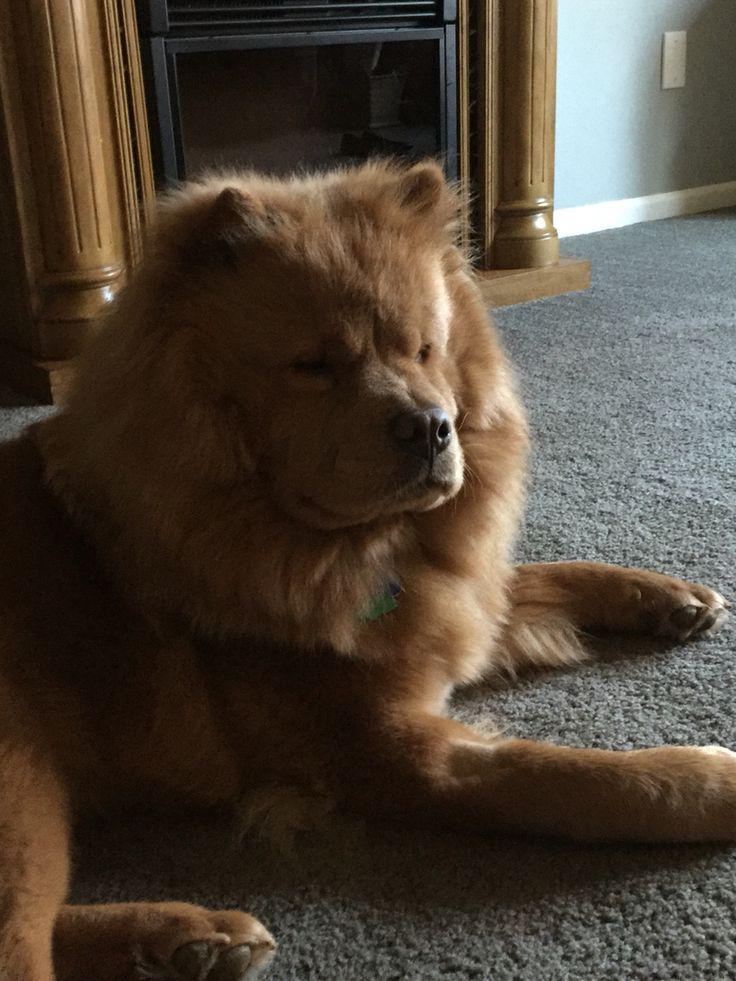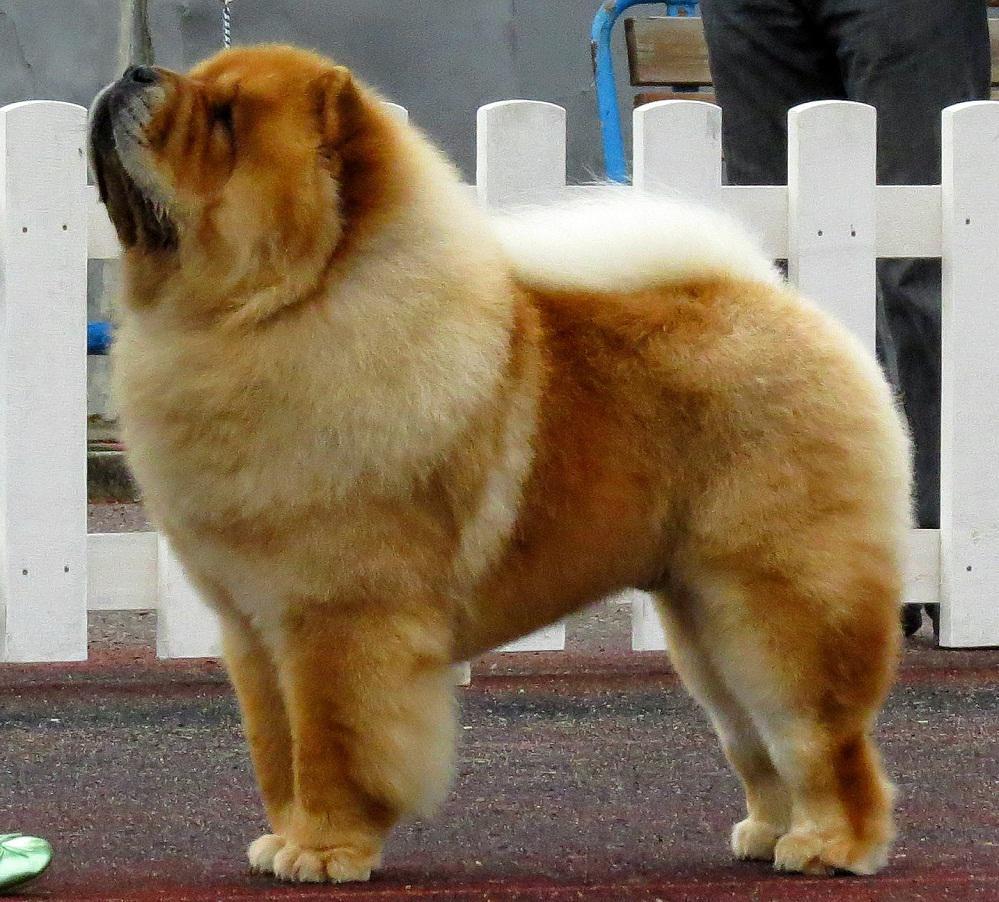The first image is the image on the left, the second image is the image on the right. Assess this claim about the two images: "The dog in the image on the right is standing on all fours.". Correct or not? Answer yes or no. Yes. The first image is the image on the left, the second image is the image on the right. For the images shown, is this caption "Each image contains one dog, and the dog on the right is standing, while the dog on the left is reclining." true? Answer yes or no. Yes. 